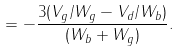<formula> <loc_0><loc_0><loc_500><loc_500>= - \frac { 3 ( V _ { g } / W _ { g } - V _ { d } / W _ { b } ) } { ( W _ { b } + W _ { g } ) } .</formula> 